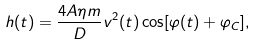Convert formula to latex. <formula><loc_0><loc_0><loc_500><loc_500>h ( t ) = \frac { 4 A \eta m } { D } v ^ { 2 } ( t ) \cos [ \varphi ( t ) + \varphi _ { C } ] ,</formula> 